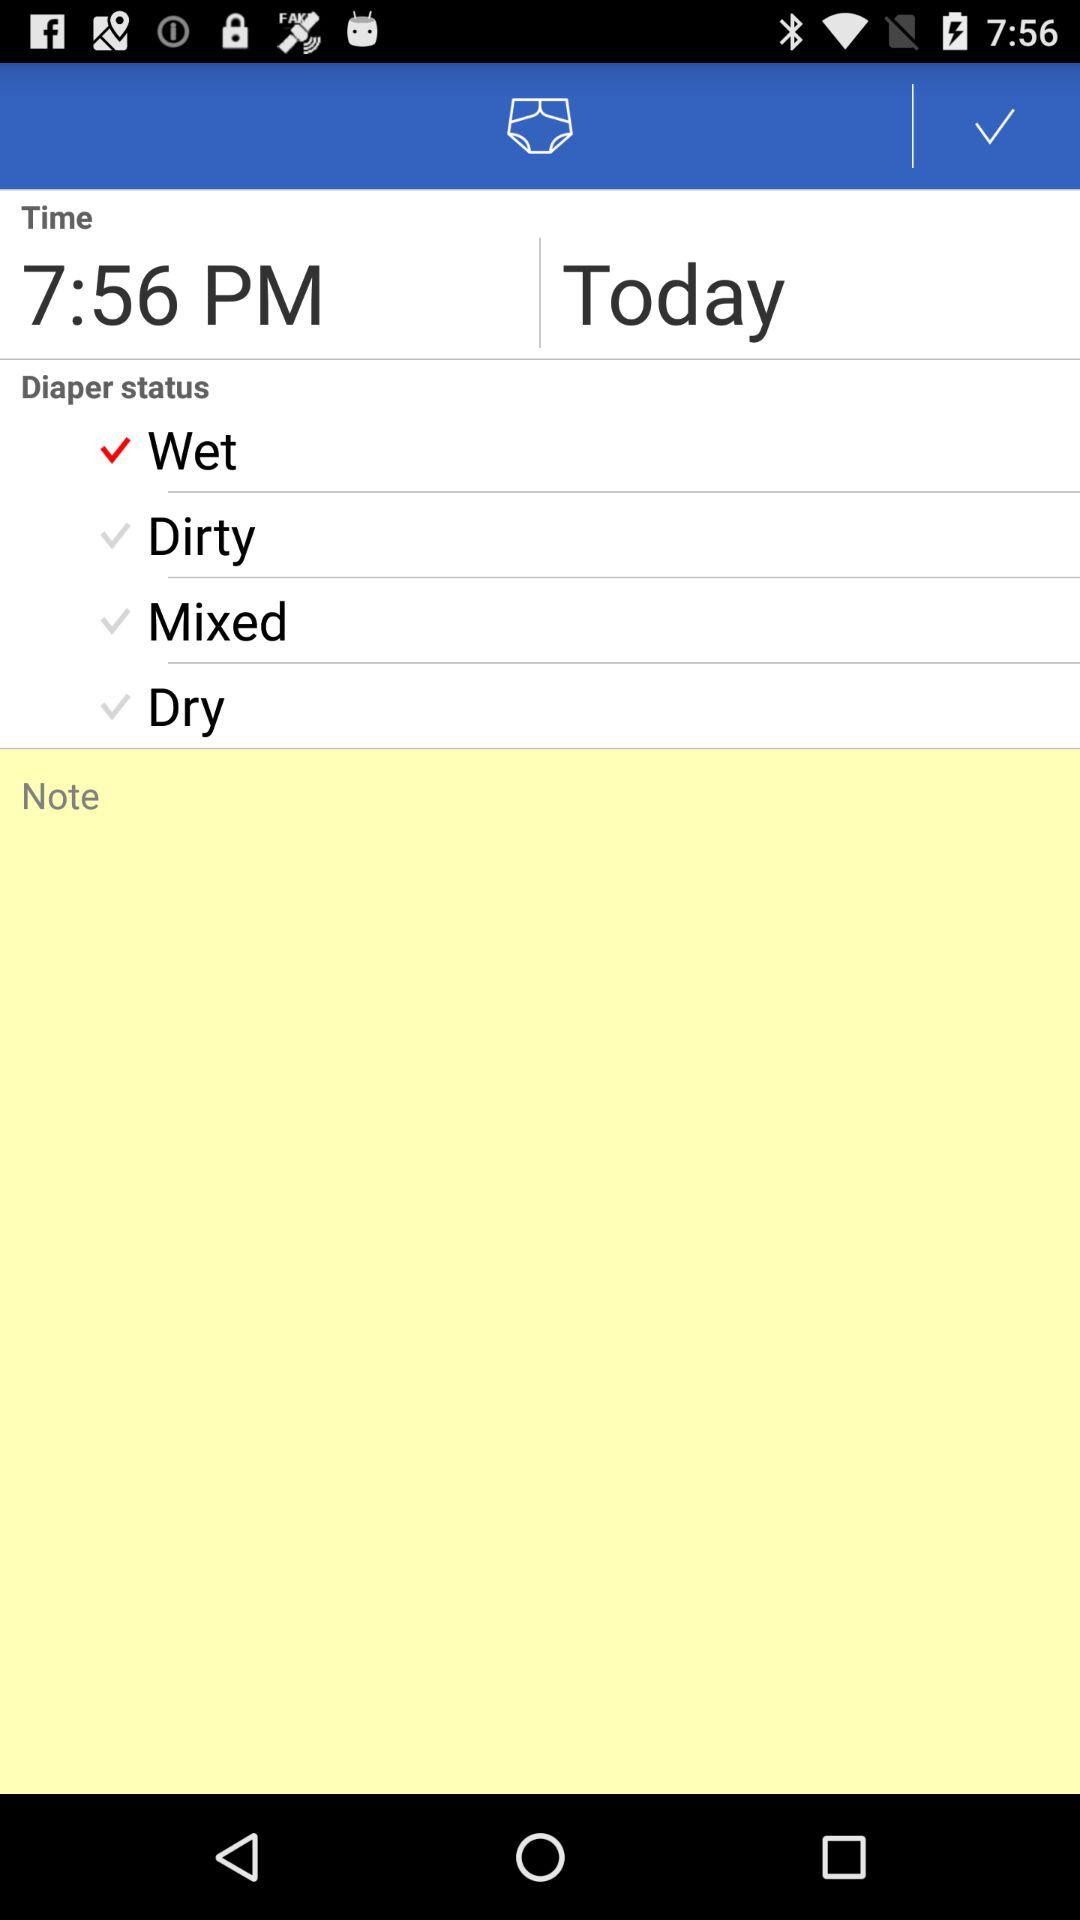Which option is selected in "Diaper status"? The selected option is "Wet". 